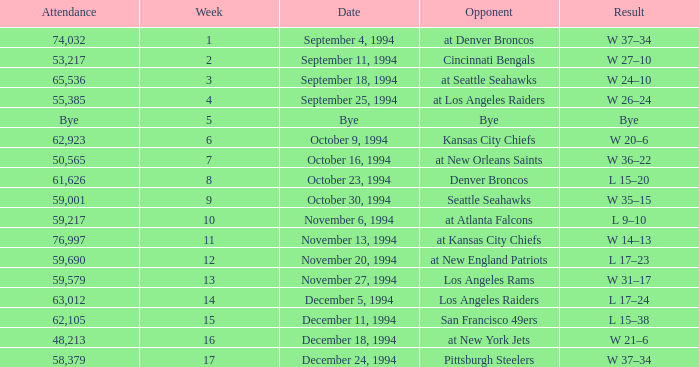Parse the full table. {'header': ['Attendance', 'Week', 'Date', 'Opponent', 'Result'], 'rows': [['74,032', '1', 'September 4, 1994', 'at Denver Broncos', 'W 37–34'], ['53,217', '2', 'September 11, 1994', 'Cincinnati Bengals', 'W 27–10'], ['65,536', '3', 'September 18, 1994', 'at Seattle Seahawks', 'W 24–10'], ['55,385', '4', 'September 25, 1994', 'at Los Angeles Raiders', 'W 26–24'], ['Bye', '5', 'Bye', 'Bye', 'Bye'], ['62,923', '6', 'October 9, 1994', 'Kansas City Chiefs', 'W 20–6'], ['50,565', '7', 'October 16, 1994', 'at New Orleans Saints', 'W 36–22'], ['61,626', '8', 'October 23, 1994', 'Denver Broncos', 'L 15–20'], ['59,001', '9', 'October 30, 1994', 'Seattle Seahawks', 'W 35–15'], ['59,217', '10', 'November 6, 1994', 'at Atlanta Falcons', 'L 9–10'], ['76,997', '11', 'November 13, 1994', 'at Kansas City Chiefs', 'W 14–13'], ['59,690', '12', 'November 20, 1994', 'at New England Patriots', 'L 17–23'], ['59,579', '13', 'November 27, 1994', 'Los Angeles Rams', 'W 31–17'], ['63,012', '14', 'December 5, 1994', 'Los Angeles Raiders', 'L 17–24'], ['62,105', '15', 'December 11, 1994', 'San Francisco 49ers', 'L 15–38'], ['48,213', '16', 'December 18, 1994', 'at New York Jets', 'W 21–6'], ['58,379', '17', 'December 24, 1994', 'Pittsburgh Steelers', 'W 37–34']]} In the game on or before week 9, who was the opponent when the attendance was 61,626? Denver Broncos. 